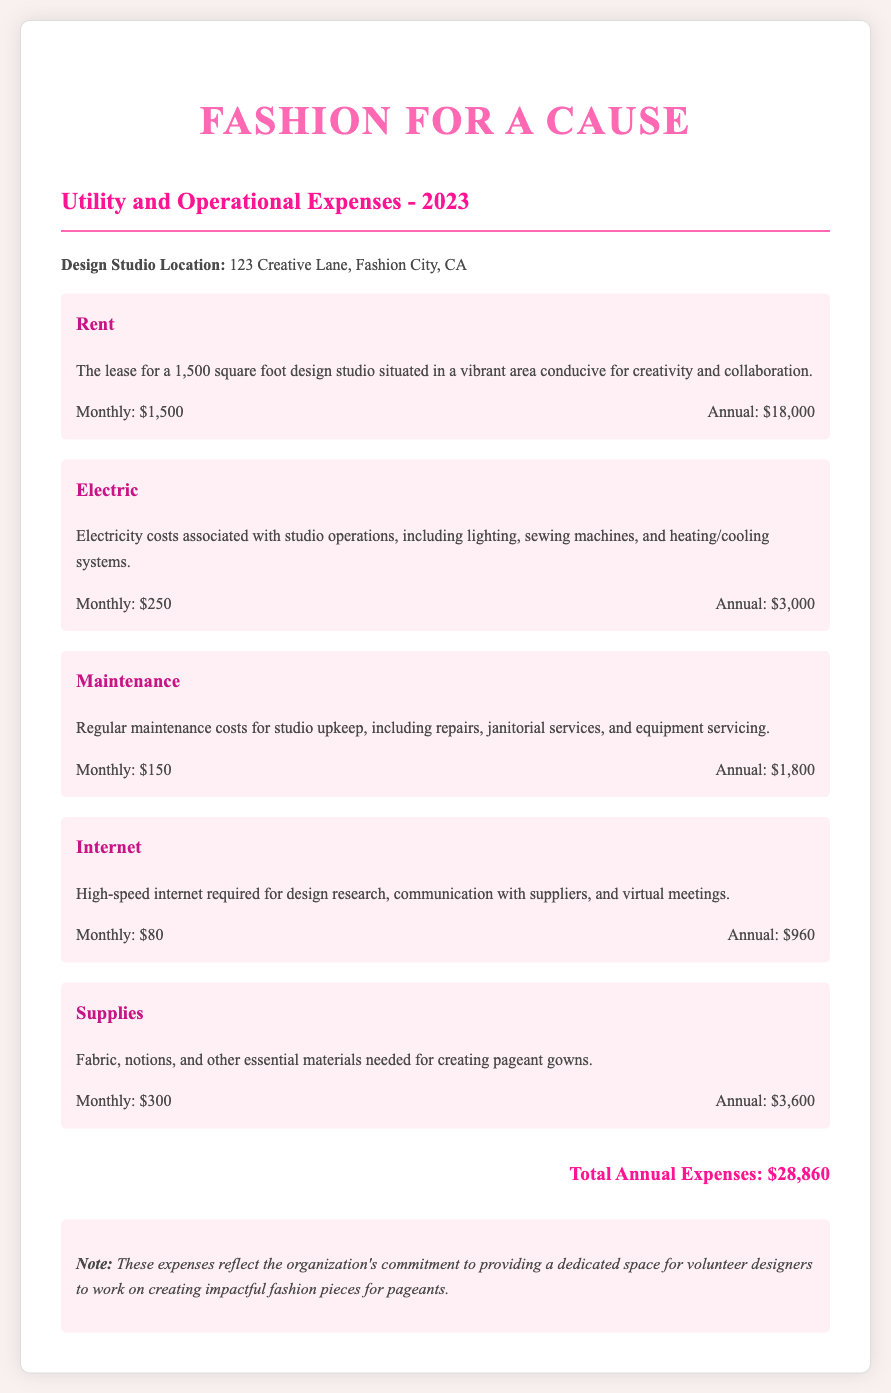what is the monthly rent? The monthly rent is stated in the document as $1,500.
Answer: $1,500 what are the annual electric expenses? The annual electric expenses can be found by multiplying the monthly costs by 12, which is $250 monthly, totaling $3,000.
Answer: $3,000 how much is spent monthly on maintenance? The document specifies that monthly maintenance costs are $150.
Answer: $150 what is the location of the design studio? The design studio is located at 123 Creative Lane, Fashion City, CA.
Answer: 123 Creative Lane, Fashion City, CA what is the total annual expense? The document summarizes total annual expenses as $28,860, which includes all utility and operational costs.
Answer: $28,860 what type of internet service is required? The document mentions high-speed internet is required for various studio operations.
Answer: High-speed internet how much do supplies cost annually? Supplies are documented to cost $300 monthly, which amounts to $3,600 annually.
Answer: $3,600 what are the key components of operational expenses? The key components of operational expenses include rent, electric, maintenance, internet, and supplies.
Answer: Rent, electric, maintenance, internet, and supplies why is regular maintenance necessary? Regular maintenance is crucial for studio upkeep, repairs, janitorial services, and equipment servicing, as outlined in the document.
Answer: For studio upkeep and repairs 